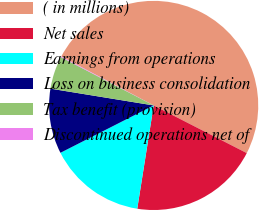Convert chart to OTSL. <chart><loc_0><loc_0><loc_500><loc_500><pie_chart><fcel>( in millions)<fcel>Net sales<fcel>Earnings from operations<fcel>Loss on business consolidation<fcel>Tax benefit (provision)<fcel>Discontinued operations net of<nl><fcel>49.77%<fcel>19.98%<fcel>15.01%<fcel>10.05%<fcel>5.08%<fcel>0.11%<nl></chart> 